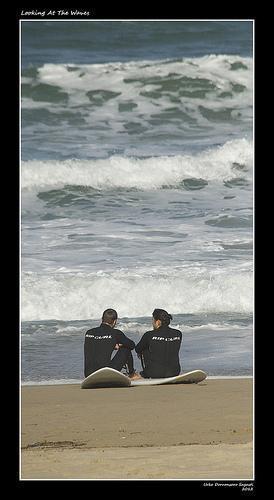How many people sitting on the shore?
Give a very brief answer. 2. 